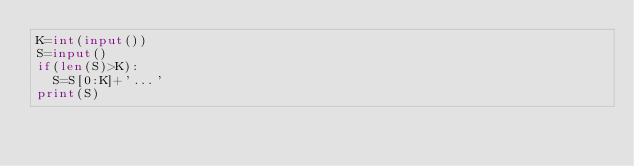<code> <loc_0><loc_0><loc_500><loc_500><_Python_>K=int(input())
S=input()
if(len(S)>K):
	S=S[0:K]+'...'
print(S)</code> 